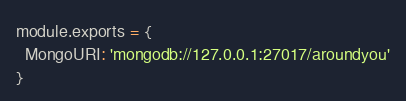<code> <loc_0><loc_0><loc_500><loc_500><_JavaScript_>module.exports = {
  MongoURI: 'mongodb://127.0.0.1:27017/aroundyou'
}</code> 